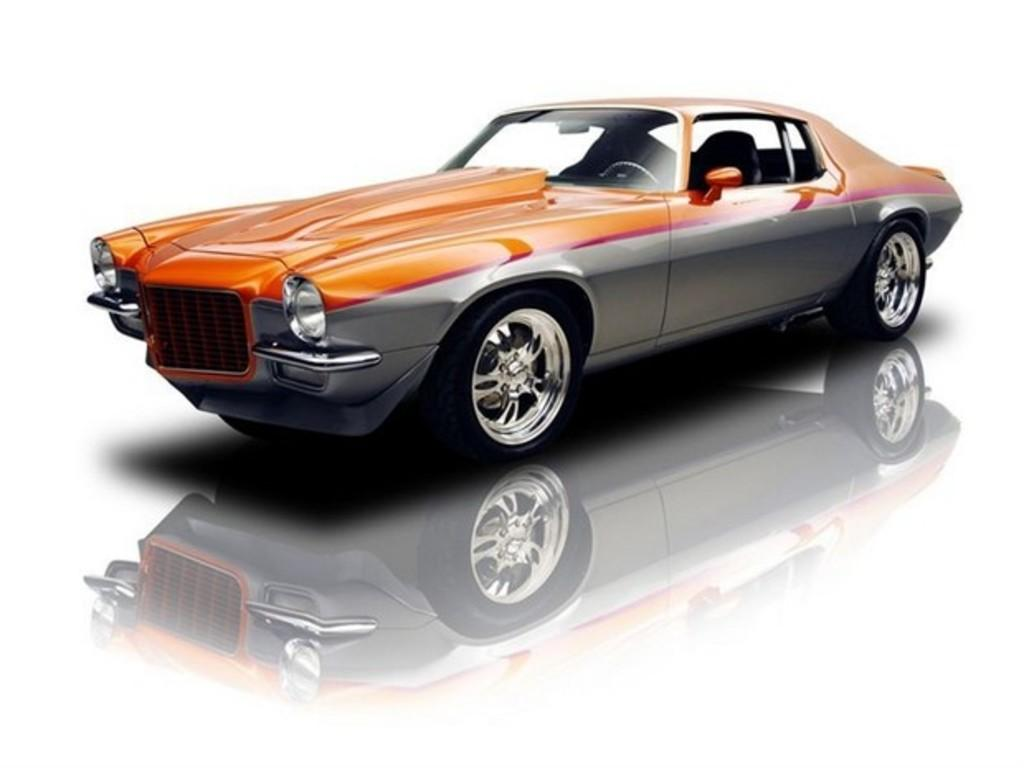What is the main subject of the image? The main subject of the image is a car. Can you describe any additional features of the car in the image? The car has a shadow on the floor. What type of seed is being planted in the car's engine in the image? There is no seed or planting activity present in the image; it only features a car with a shadow on the floor. 